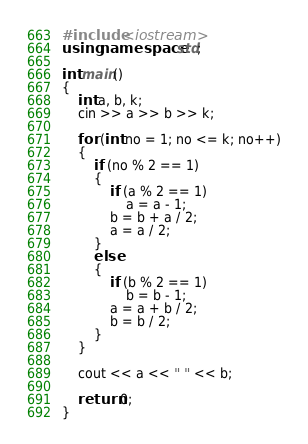<code> <loc_0><loc_0><loc_500><loc_500><_C++_>#include <iostream>
using namespace std;

int main()
{
    int a, b, k;
    cin >> a >> b >> k;

    for (int no = 1; no <= k; no++)
    {
        if (no % 2 == 1)
        {
            if (a % 2 == 1)
                a = a - 1;
            b = b + a / 2;
            a = a / 2;
        }
        else
        {
            if (b % 2 == 1)
                b = b - 1;
            a = a + b / 2;
            b = b / 2;
        }
    }

    cout << a << " " << b;

    return 0;
}</code> 